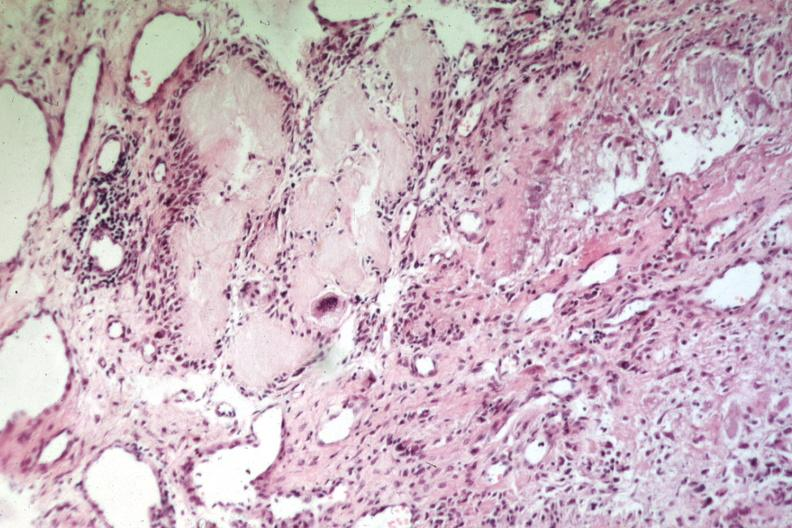what does this image show?
Answer the question using a single word or phrase. Uric acid deposits with giant cells easily recognizable as gout or uric acid tophus 